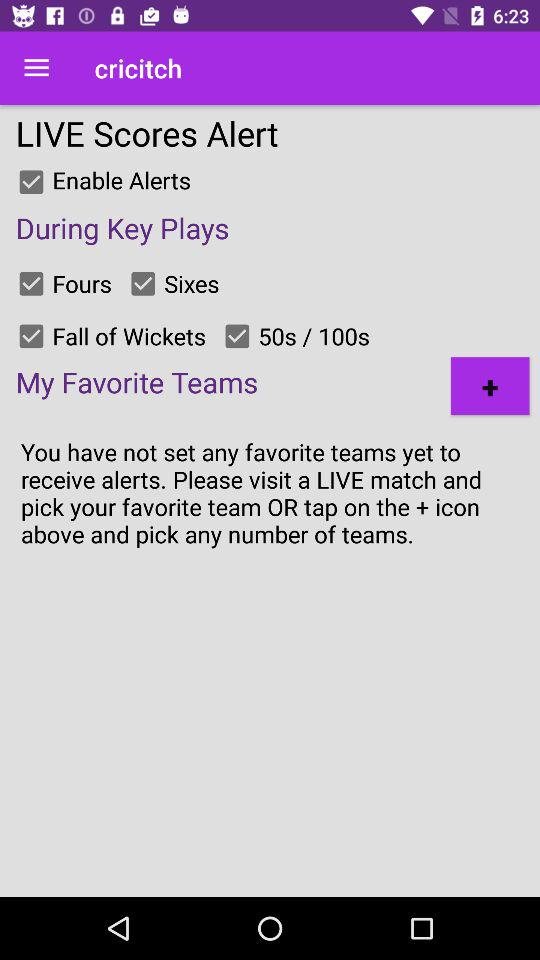What is the current status of "Fours"? The current status is "on". 